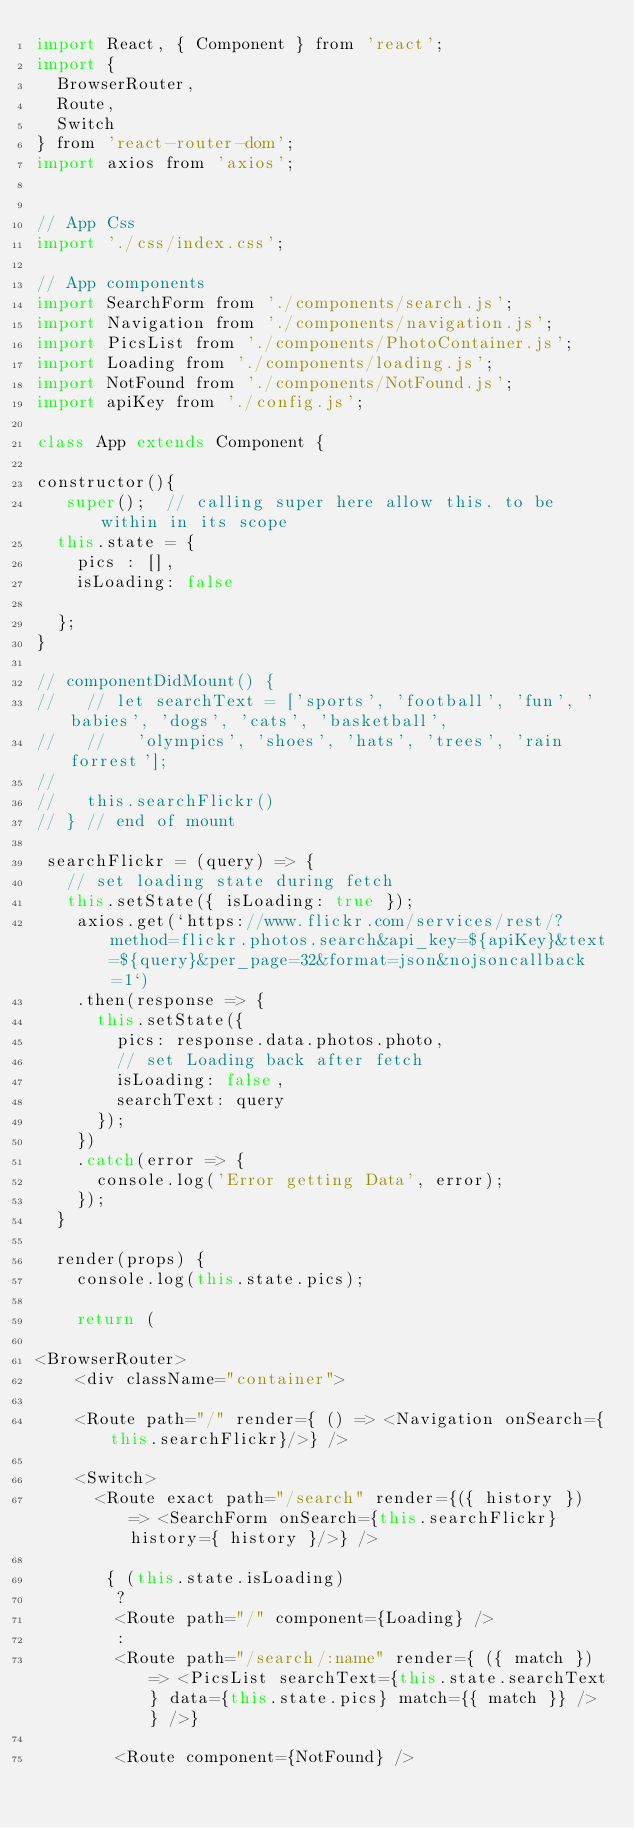Convert code to text. <code><loc_0><loc_0><loc_500><loc_500><_JavaScript_>import React, { Component } from 'react';
import {
  BrowserRouter,
  Route,
  Switch
} from 'react-router-dom';
import axios from 'axios';


// App Css
import './css/index.css';

// App components
import SearchForm from './components/search.js';
import Navigation from './components/navigation.js';
import PicsList from './components/PhotoContainer.js';
import Loading from './components/loading.js';
import NotFound from './components/NotFound.js';
import apiKey from './config.js';

class App extends Component {

constructor(){
   super();  // calling super here allow this. to be within in its scope
  this.state = {
    pics : [],
    isLoading: false

  };
}

// componentDidMount() {
//   // let searchText = ['sports', 'football', 'fun', 'babies', 'dogs', 'cats', 'basketball',
//   //   'olympics', 'shoes', 'hats', 'trees', 'rain forrest'];
//
//   this.searchFlickr()
// } // end of mount

 searchFlickr = (query) => {
   // set loading state during fetch
   this.setState({ isLoading: true });
    axios.get(`https://www.flickr.com/services/rest/?method=flickr.photos.search&api_key=${apiKey}&text=${query}&per_page=32&format=json&nojsoncallback=1`)
    .then(response => {
      this.setState({
        pics: response.data.photos.photo,
        // set Loading back after fetch
        isLoading: false,
        searchText: query
      });
    })
    .catch(error => {
      console.log('Error getting Data', error);
    });
  }

  render(props) {
    console.log(this.state.pics);

    return (

<BrowserRouter>
    <div className="container">

    <Route path="/" render={ () => <Navigation onSearch={this.searchFlickr}/>} />

    <Switch>
      <Route exact path="/search" render={({ history }) => <SearchForm onSearch={this.searchFlickr} history={ history }/>} />

       { (this.state.isLoading)
        ?
        <Route path="/" component={Loading} />
        :
        <Route path="/search/:name" render={ ({ match }) => <PicsList searchText={this.state.searchText} data={this.state.pics} match={{ match }} /> } />}

        <Route component={NotFound} /></code> 